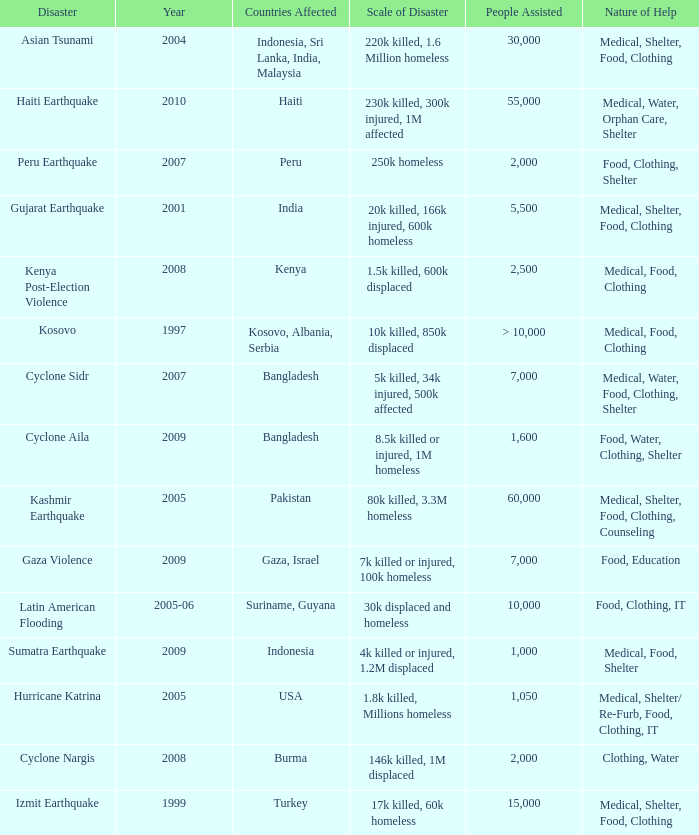How many people were assisted in 1997? > 10,000. 